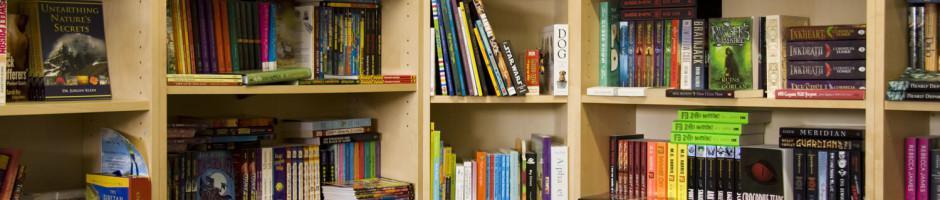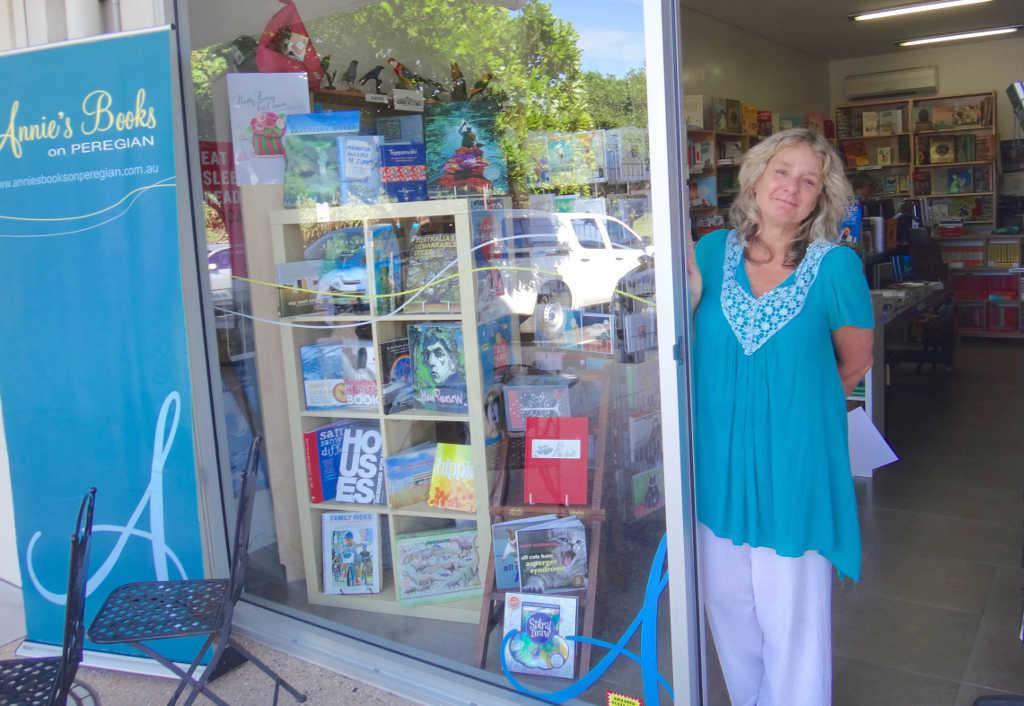The first image is the image on the left, the second image is the image on the right. For the images displayed, is the sentence "In one image, a blond woman has an arm around the man next to her, and a woman on the other side of him has her elbow bent, and they are standing in front of books on shelves." factually correct? Answer yes or no. No. The first image is the image on the left, the second image is the image on the right. Given the left and right images, does the statement "An author is posing with fans." hold true? Answer yes or no. No. 